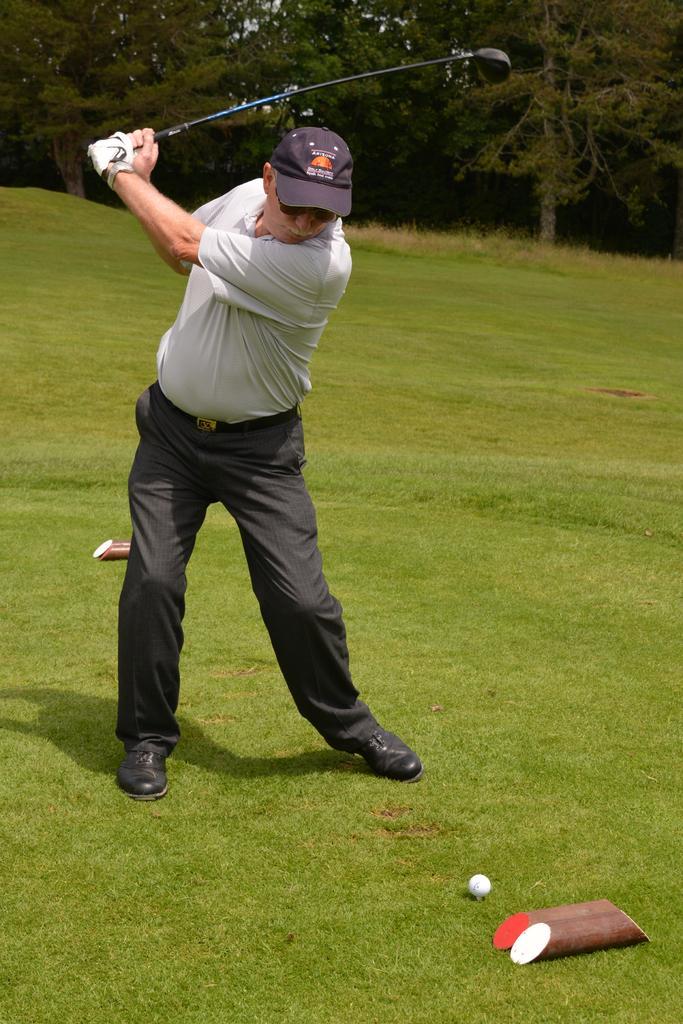Can you describe this image briefly? In this picture we can see a person standing on the ground,he is holding a stick,here we can see a ball on the ground and in the background we can see trees. 